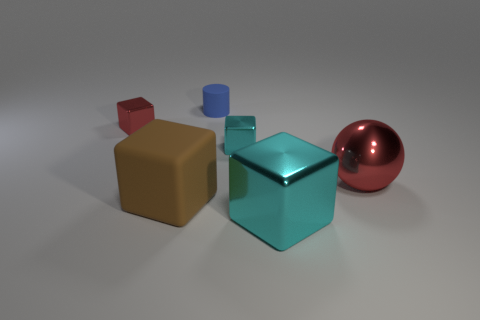Add 1 brown cubes. How many objects exist? 7 Subtract all spheres. How many objects are left? 5 Subtract all tiny red things. Subtract all big objects. How many objects are left? 2 Add 5 tiny blue objects. How many tiny blue objects are left? 6 Add 6 tiny red metal cubes. How many tiny red metal cubes exist? 7 Subtract 0 green spheres. How many objects are left? 6 